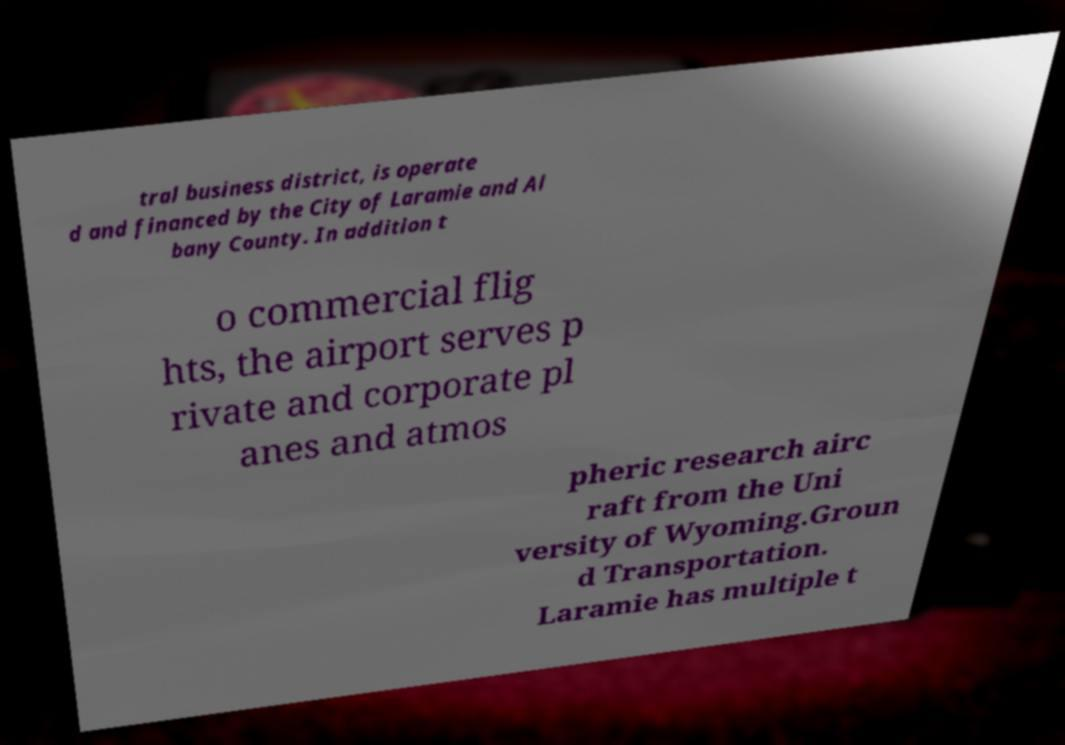I need the written content from this picture converted into text. Can you do that? tral business district, is operate d and financed by the City of Laramie and Al bany County. In addition t o commercial flig hts, the airport serves p rivate and corporate pl anes and atmos pheric research airc raft from the Uni versity of Wyoming.Groun d Transportation. Laramie has multiple t 